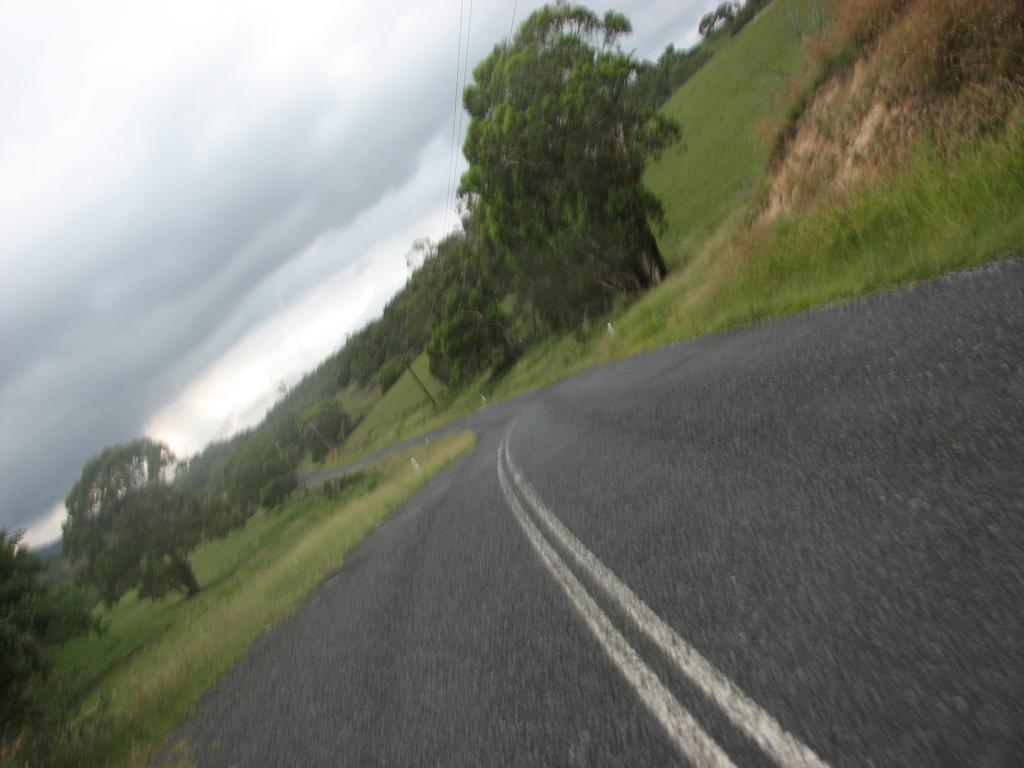What can be seen in the background of the image? The sky is visible in the image. What type of surface is present in the image? There is a road in the image. What type of vegetation is present in the image? Grass is present in the image. What other natural elements can be seen in the image? Trees are visible in the image. Where are the pies being baked in the image? There are no pies or any indication of baking in the image. What type of plantation can be seen in the image? There is no plantation present in the image; it features a sky, road, grass, and trees. 